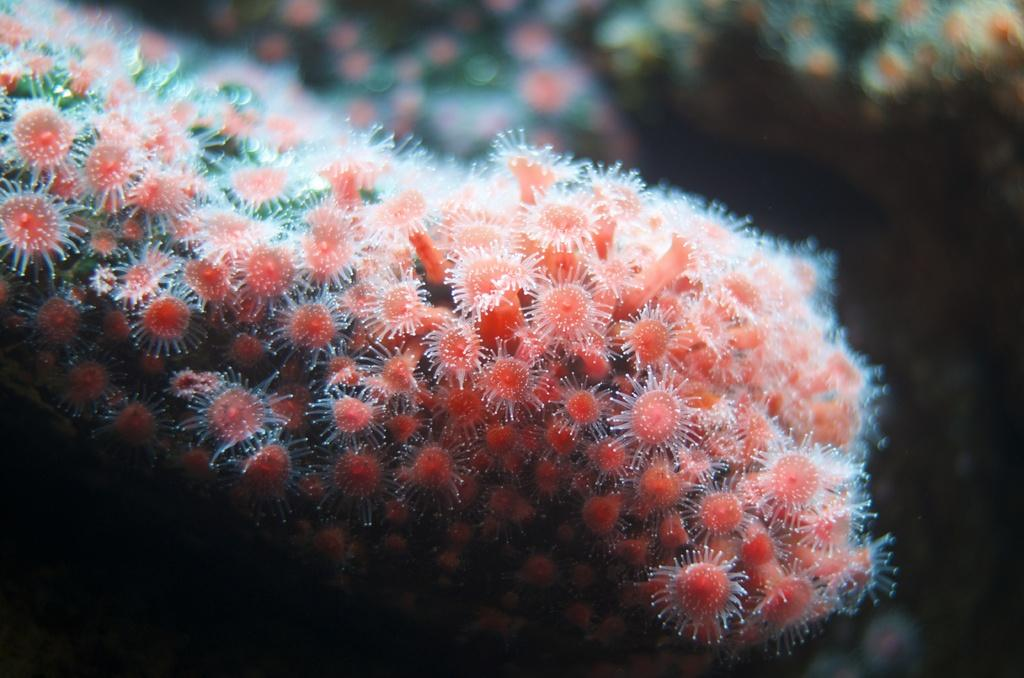What type of natural formation is present in the image? The image contains coral reef. What is the color of the coral reef? The coral reef is in red color. What can be seen in the background of the image? The background of the image is black in color. How is the background of the image depicted? The background is blurred. What type of pancake is being served in the image? There is no pancake present in the image; it features coral reef and a black background. 